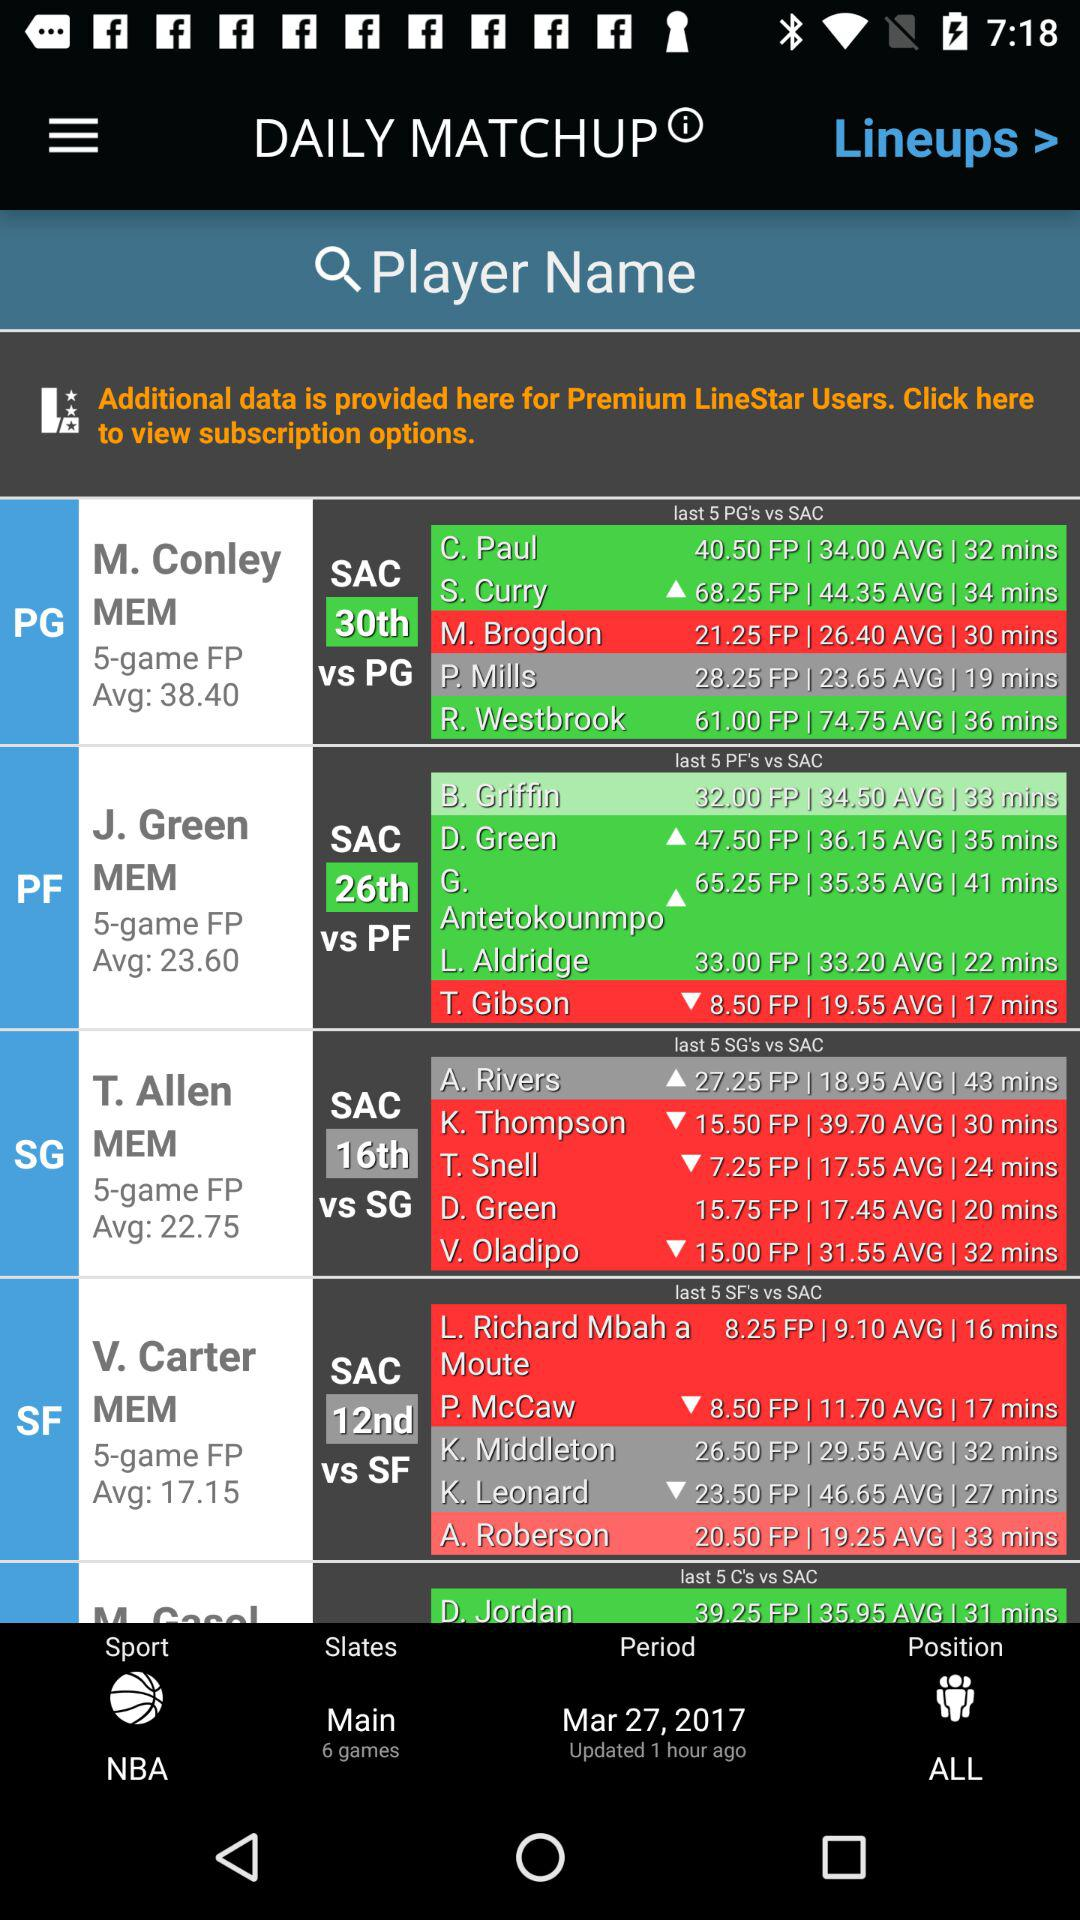How many main games are there? There are 5 games. 